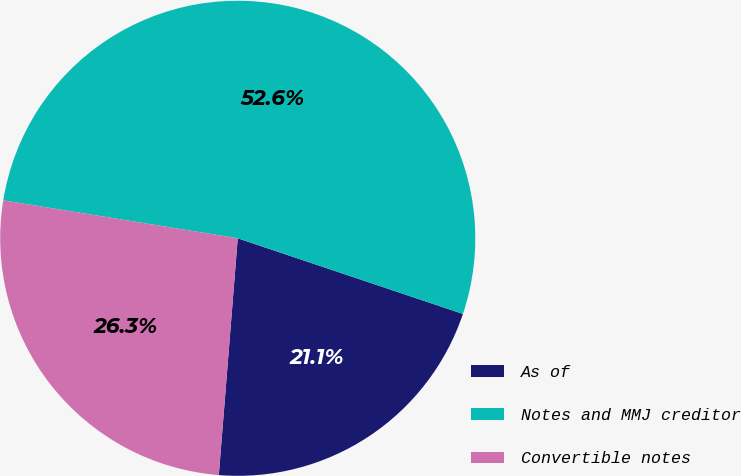Convert chart. <chart><loc_0><loc_0><loc_500><loc_500><pie_chart><fcel>As of<fcel>Notes and MMJ creditor<fcel>Convertible notes<nl><fcel>21.11%<fcel>52.6%<fcel>26.28%<nl></chart> 